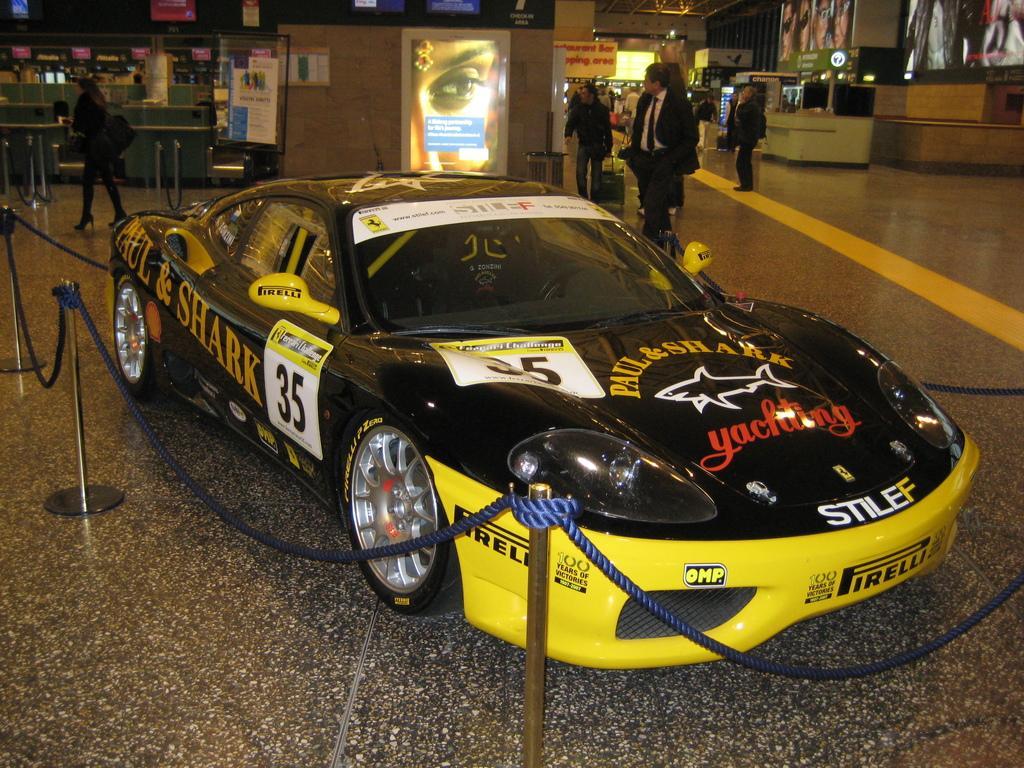Can you describe this image briefly? In the center of the image we can see a car and poles with ropes. And we can see some text on the car. In the background, there is a wall, screens, few people and a few other objects. 